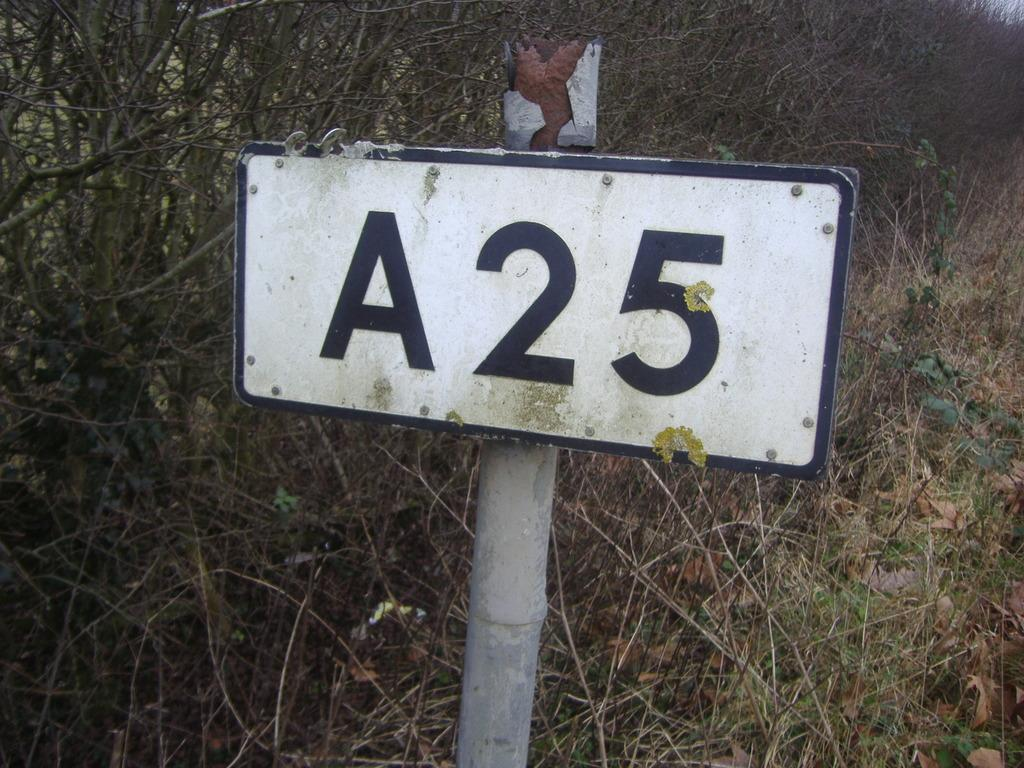<image>
Offer a succinct explanation of the picture presented. Old white sign on a pole which says A25 on it. 